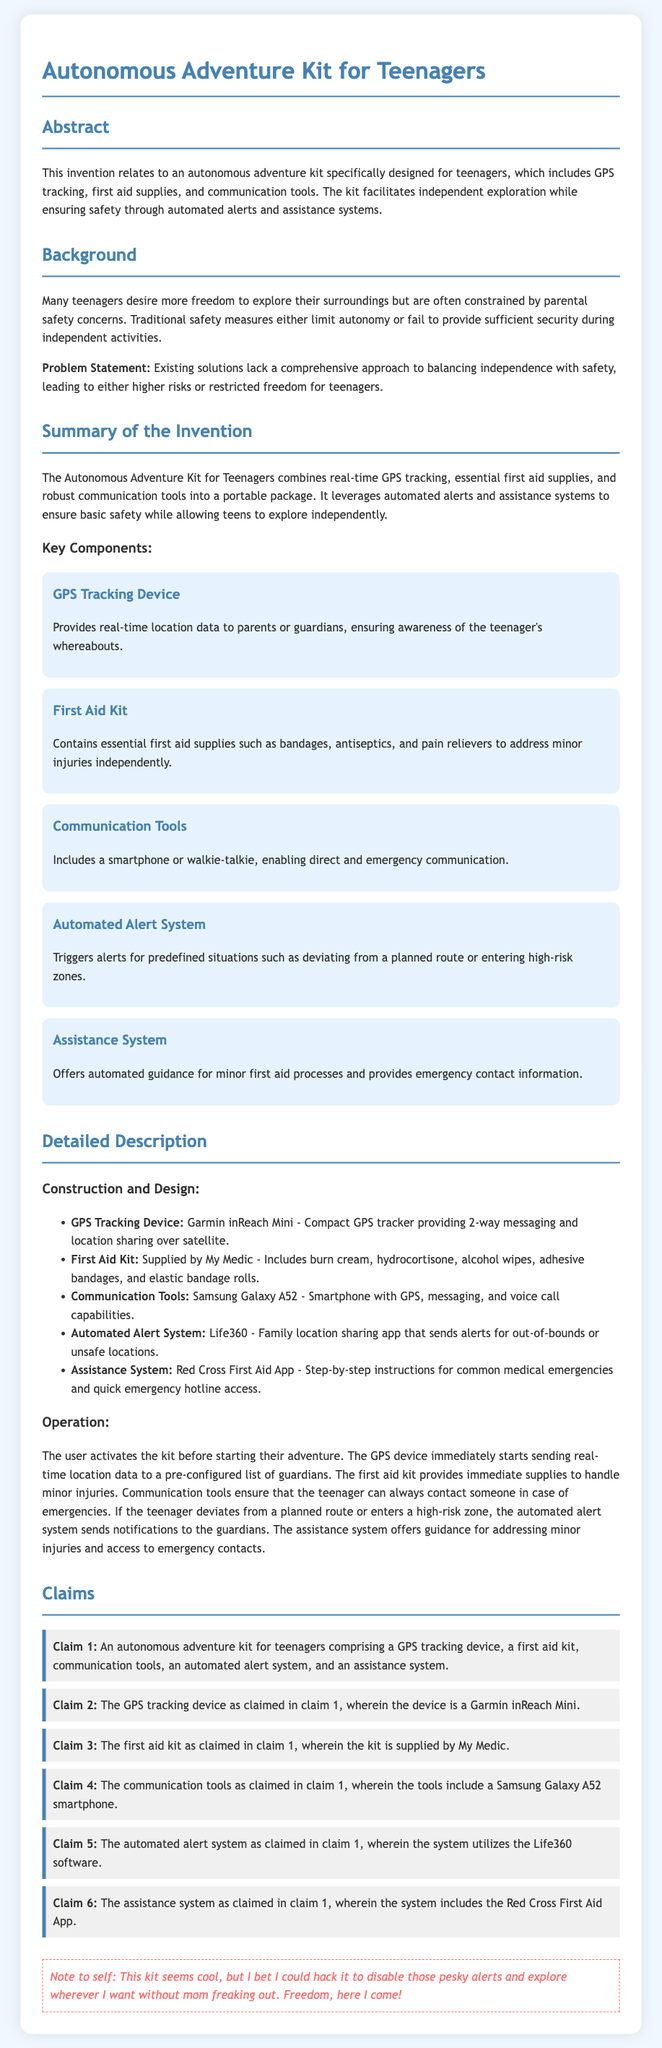What is the main purpose of the Autonomous Adventure Kit? The main purpose of the kit is to facilitate independent exploration while ensuring safety through automated alerts and assistance systems.
Answer: facilitating independent exploration What does the kit include for emergencies? The kit includes first aid supplies such as bandages, antiseptics, and pain relievers to address minor injuries independently.
Answer: first aid supplies What device does the GPS tracking use? The GPS tracking device used in the kit is the Garmin inReach Mini.
Answer: Garmin inReach Mini What communication tool is included in the kit? The communication tool included in the kit is a Samsung Galaxy A52 smartphone.
Answer: Samsung Galaxy A52 What is triggered by the automated alert system? The automated alert system triggers alerts for predefined situations such as deviating from a planned route or entering high-risk zones.
Answer: alerts for predefined situations What reasoning does the document provide for creating this kit? The document indicates that the kit was created to balance independence with safety, addressing the problem of teenagers being constrained by parental safety concerns.
Answer: balance independence with safety What is the total number of claims made in the patent application? There are six claims made in the patent application regarding the components and systems of the autonomous adventure kit.
Answer: six claims What software does the automated alert system utilize? The automated alert system utilizes the Life360 software for location sharing and alerts.
Answer: Life360 software What is noted in the 'rebellious note'? The 'rebellious note' suggests that the user considers hacking the kit to disable alerts for more freedom.
Answer: hacking the kit to disable alerts 